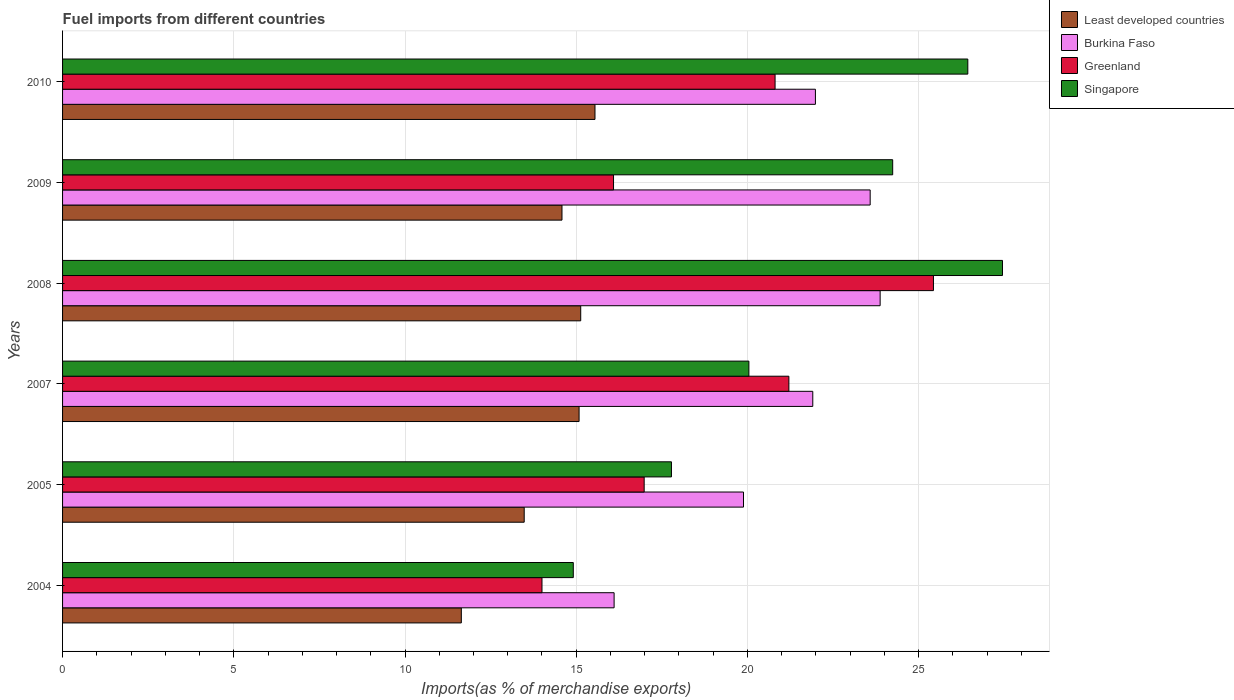How many groups of bars are there?
Offer a terse response. 6. Are the number of bars per tick equal to the number of legend labels?
Offer a terse response. Yes. Are the number of bars on each tick of the Y-axis equal?
Give a very brief answer. Yes. How many bars are there on the 2nd tick from the top?
Make the answer very short. 4. How many bars are there on the 4th tick from the bottom?
Your response must be concise. 4. What is the label of the 2nd group of bars from the top?
Your answer should be compact. 2009. What is the percentage of imports to different countries in Burkina Faso in 2010?
Ensure brevity in your answer.  21.98. Across all years, what is the maximum percentage of imports to different countries in Greenland?
Provide a succinct answer. 25.43. Across all years, what is the minimum percentage of imports to different countries in Burkina Faso?
Give a very brief answer. 16.11. In which year was the percentage of imports to different countries in Burkina Faso minimum?
Provide a succinct answer. 2004. What is the total percentage of imports to different countries in Least developed countries in the graph?
Your response must be concise. 85.47. What is the difference between the percentage of imports to different countries in Singapore in 2004 and that in 2009?
Your answer should be very brief. -9.33. What is the difference between the percentage of imports to different countries in Least developed countries in 2005 and the percentage of imports to different countries in Burkina Faso in 2007?
Keep it short and to the point. -8.43. What is the average percentage of imports to different countries in Least developed countries per year?
Provide a short and direct response. 14.25. In the year 2008, what is the difference between the percentage of imports to different countries in Burkina Faso and percentage of imports to different countries in Greenland?
Your answer should be very brief. -1.56. What is the ratio of the percentage of imports to different countries in Greenland in 2009 to that in 2010?
Provide a succinct answer. 0.77. Is the percentage of imports to different countries in Singapore in 2004 less than that in 2005?
Provide a succinct answer. Yes. What is the difference between the highest and the second highest percentage of imports to different countries in Greenland?
Ensure brevity in your answer.  4.22. What is the difference between the highest and the lowest percentage of imports to different countries in Burkina Faso?
Provide a short and direct response. 7.77. What does the 2nd bar from the top in 2010 represents?
Your response must be concise. Greenland. What does the 3rd bar from the bottom in 2007 represents?
Provide a short and direct response. Greenland. How many bars are there?
Provide a short and direct response. 24. Are all the bars in the graph horizontal?
Your answer should be compact. Yes. How many years are there in the graph?
Offer a terse response. 6. Does the graph contain any zero values?
Give a very brief answer. No. Does the graph contain grids?
Give a very brief answer. Yes. Where does the legend appear in the graph?
Offer a terse response. Top right. How many legend labels are there?
Your answer should be compact. 4. What is the title of the graph?
Your answer should be very brief. Fuel imports from different countries. Does "Bahamas" appear as one of the legend labels in the graph?
Offer a terse response. No. What is the label or title of the X-axis?
Make the answer very short. Imports(as % of merchandise exports). What is the label or title of the Y-axis?
Provide a succinct answer. Years. What is the Imports(as % of merchandise exports) in Least developed countries in 2004?
Your answer should be compact. 11.64. What is the Imports(as % of merchandise exports) of Burkina Faso in 2004?
Provide a succinct answer. 16.11. What is the Imports(as % of merchandise exports) in Greenland in 2004?
Your answer should be very brief. 14. What is the Imports(as % of merchandise exports) of Singapore in 2004?
Make the answer very short. 14.91. What is the Imports(as % of merchandise exports) in Least developed countries in 2005?
Ensure brevity in your answer.  13.48. What is the Imports(as % of merchandise exports) in Burkina Faso in 2005?
Provide a short and direct response. 19.88. What is the Imports(as % of merchandise exports) of Greenland in 2005?
Your answer should be very brief. 16.98. What is the Imports(as % of merchandise exports) in Singapore in 2005?
Provide a succinct answer. 17.78. What is the Imports(as % of merchandise exports) of Least developed countries in 2007?
Provide a succinct answer. 15.08. What is the Imports(as % of merchandise exports) in Burkina Faso in 2007?
Give a very brief answer. 21.91. What is the Imports(as % of merchandise exports) in Greenland in 2007?
Ensure brevity in your answer.  21.21. What is the Imports(as % of merchandise exports) in Singapore in 2007?
Your answer should be very brief. 20.04. What is the Imports(as % of merchandise exports) of Least developed countries in 2008?
Your answer should be compact. 15.13. What is the Imports(as % of merchandise exports) of Burkina Faso in 2008?
Your response must be concise. 23.87. What is the Imports(as % of merchandise exports) in Greenland in 2008?
Make the answer very short. 25.43. What is the Imports(as % of merchandise exports) of Singapore in 2008?
Offer a terse response. 27.45. What is the Imports(as % of merchandise exports) of Least developed countries in 2009?
Offer a terse response. 14.58. What is the Imports(as % of merchandise exports) in Burkina Faso in 2009?
Offer a very short reply. 23.58. What is the Imports(as % of merchandise exports) in Greenland in 2009?
Give a very brief answer. 16.09. What is the Imports(as % of merchandise exports) in Singapore in 2009?
Give a very brief answer. 24.24. What is the Imports(as % of merchandise exports) of Least developed countries in 2010?
Keep it short and to the point. 15.55. What is the Imports(as % of merchandise exports) in Burkina Faso in 2010?
Provide a short and direct response. 21.98. What is the Imports(as % of merchandise exports) in Greenland in 2010?
Make the answer very short. 20.81. What is the Imports(as % of merchandise exports) in Singapore in 2010?
Make the answer very short. 26.43. Across all years, what is the maximum Imports(as % of merchandise exports) in Least developed countries?
Offer a terse response. 15.55. Across all years, what is the maximum Imports(as % of merchandise exports) of Burkina Faso?
Your response must be concise. 23.87. Across all years, what is the maximum Imports(as % of merchandise exports) of Greenland?
Make the answer very short. 25.43. Across all years, what is the maximum Imports(as % of merchandise exports) in Singapore?
Your response must be concise. 27.45. Across all years, what is the minimum Imports(as % of merchandise exports) in Least developed countries?
Provide a short and direct response. 11.64. Across all years, what is the minimum Imports(as % of merchandise exports) in Burkina Faso?
Provide a short and direct response. 16.11. Across all years, what is the minimum Imports(as % of merchandise exports) of Greenland?
Ensure brevity in your answer.  14. Across all years, what is the minimum Imports(as % of merchandise exports) in Singapore?
Give a very brief answer. 14.91. What is the total Imports(as % of merchandise exports) in Least developed countries in the graph?
Provide a short and direct response. 85.47. What is the total Imports(as % of merchandise exports) in Burkina Faso in the graph?
Your answer should be compact. 127.34. What is the total Imports(as % of merchandise exports) in Greenland in the graph?
Give a very brief answer. 114.52. What is the total Imports(as % of merchandise exports) in Singapore in the graph?
Offer a terse response. 130.86. What is the difference between the Imports(as % of merchandise exports) in Least developed countries in 2004 and that in 2005?
Ensure brevity in your answer.  -1.84. What is the difference between the Imports(as % of merchandise exports) in Burkina Faso in 2004 and that in 2005?
Offer a very short reply. -3.78. What is the difference between the Imports(as % of merchandise exports) of Greenland in 2004 and that in 2005?
Provide a succinct answer. -2.98. What is the difference between the Imports(as % of merchandise exports) in Singapore in 2004 and that in 2005?
Provide a short and direct response. -2.87. What is the difference between the Imports(as % of merchandise exports) of Least developed countries in 2004 and that in 2007?
Your answer should be compact. -3.44. What is the difference between the Imports(as % of merchandise exports) of Burkina Faso in 2004 and that in 2007?
Provide a short and direct response. -5.8. What is the difference between the Imports(as % of merchandise exports) in Greenland in 2004 and that in 2007?
Provide a succinct answer. -7.21. What is the difference between the Imports(as % of merchandise exports) in Singapore in 2004 and that in 2007?
Ensure brevity in your answer.  -5.13. What is the difference between the Imports(as % of merchandise exports) of Least developed countries in 2004 and that in 2008?
Provide a short and direct response. -3.49. What is the difference between the Imports(as % of merchandise exports) of Burkina Faso in 2004 and that in 2008?
Your answer should be very brief. -7.77. What is the difference between the Imports(as % of merchandise exports) of Greenland in 2004 and that in 2008?
Give a very brief answer. -11.43. What is the difference between the Imports(as % of merchandise exports) in Singapore in 2004 and that in 2008?
Give a very brief answer. -12.53. What is the difference between the Imports(as % of merchandise exports) of Least developed countries in 2004 and that in 2009?
Give a very brief answer. -2.94. What is the difference between the Imports(as % of merchandise exports) in Burkina Faso in 2004 and that in 2009?
Provide a short and direct response. -7.48. What is the difference between the Imports(as % of merchandise exports) in Greenland in 2004 and that in 2009?
Keep it short and to the point. -2.09. What is the difference between the Imports(as % of merchandise exports) in Singapore in 2004 and that in 2009?
Your response must be concise. -9.33. What is the difference between the Imports(as % of merchandise exports) of Least developed countries in 2004 and that in 2010?
Your response must be concise. -3.9. What is the difference between the Imports(as % of merchandise exports) of Burkina Faso in 2004 and that in 2010?
Your answer should be compact. -5.88. What is the difference between the Imports(as % of merchandise exports) in Greenland in 2004 and that in 2010?
Your response must be concise. -6.81. What is the difference between the Imports(as % of merchandise exports) of Singapore in 2004 and that in 2010?
Provide a succinct answer. -11.52. What is the difference between the Imports(as % of merchandise exports) of Least developed countries in 2005 and that in 2007?
Keep it short and to the point. -1.6. What is the difference between the Imports(as % of merchandise exports) of Burkina Faso in 2005 and that in 2007?
Provide a succinct answer. -2.02. What is the difference between the Imports(as % of merchandise exports) of Greenland in 2005 and that in 2007?
Provide a succinct answer. -4.23. What is the difference between the Imports(as % of merchandise exports) in Singapore in 2005 and that in 2007?
Ensure brevity in your answer.  -2.26. What is the difference between the Imports(as % of merchandise exports) of Least developed countries in 2005 and that in 2008?
Offer a terse response. -1.65. What is the difference between the Imports(as % of merchandise exports) of Burkina Faso in 2005 and that in 2008?
Offer a very short reply. -3.99. What is the difference between the Imports(as % of merchandise exports) in Greenland in 2005 and that in 2008?
Keep it short and to the point. -8.45. What is the difference between the Imports(as % of merchandise exports) in Singapore in 2005 and that in 2008?
Give a very brief answer. -9.67. What is the difference between the Imports(as % of merchandise exports) of Least developed countries in 2005 and that in 2009?
Your response must be concise. -1.1. What is the difference between the Imports(as % of merchandise exports) of Burkina Faso in 2005 and that in 2009?
Your response must be concise. -3.7. What is the difference between the Imports(as % of merchandise exports) in Greenland in 2005 and that in 2009?
Provide a short and direct response. 0.9. What is the difference between the Imports(as % of merchandise exports) of Singapore in 2005 and that in 2009?
Provide a short and direct response. -6.46. What is the difference between the Imports(as % of merchandise exports) of Least developed countries in 2005 and that in 2010?
Keep it short and to the point. -2.07. What is the difference between the Imports(as % of merchandise exports) of Burkina Faso in 2005 and that in 2010?
Your answer should be compact. -2.1. What is the difference between the Imports(as % of merchandise exports) of Greenland in 2005 and that in 2010?
Make the answer very short. -3.82. What is the difference between the Imports(as % of merchandise exports) of Singapore in 2005 and that in 2010?
Provide a short and direct response. -8.65. What is the difference between the Imports(as % of merchandise exports) of Least developed countries in 2007 and that in 2008?
Ensure brevity in your answer.  -0.05. What is the difference between the Imports(as % of merchandise exports) in Burkina Faso in 2007 and that in 2008?
Keep it short and to the point. -1.97. What is the difference between the Imports(as % of merchandise exports) of Greenland in 2007 and that in 2008?
Keep it short and to the point. -4.22. What is the difference between the Imports(as % of merchandise exports) of Singapore in 2007 and that in 2008?
Your response must be concise. -7.41. What is the difference between the Imports(as % of merchandise exports) of Least developed countries in 2007 and that in 2009?
Your response must be concise. 0.5. What is the difference between the Imports(as % of merchandise exports) in Burkina Faso in 2007 and that in 2009?
Your answer should be very brief. -1.68. What is the difference between the Imports(as % of merchandise exports) of Greenland in 2007 and that in 2009?
Give a very brief answer. 5.12. What is the difference between the Imports(as % of merchandise exports) in Singapore in 2007 and that in 2009?
Give a very brief answer. -4.2. What is the difference between the Imports(as % of merchandise exports) in Least developed countries in 2007 and that in 2010?
Ensure brevity in your answer.  -0.46. What is the difference between the Imports(as % of merchandise exports) in Burkina Faso in 2007 and that in 2010?
Offer a very short reply. -0.08. What is the difference between the Imports(as % of merchandise exports) of Greenland in 2007 and that in 2010?
Provide a succinct answer. 0.4. What is the difference between the Imports(as % of merchandise exports) of Singapore in 2007 and that in 2010?
Give a very brief answer. -6.39. What is the difference between the Imports(as % of merchandise exports) in Least developed countries in 2008 and that in 2009?
Provide a succinct answer. 0.55. What is the difference between the Imports(as % of merchandise exports) of Burkina Faso in 2008 and that in 2009?
Provide a succinct answer. 0.29. What is the difference between the Imports(as % of merchandise exports) in Greenland in 2008 and that in 2009?
Make the answer very short. 9.34. What is the difference between the Imports(as % of merchandise exports) in Singapore in 2008 and that in 2009?
Your answer should be compact. 3.21. What is the difference between the Imports(as % of merchandise exports) of Least developed countries in 2008 and that in 2010?
Offer a terse response. -0.42. What is the difference between the Imports(as % of merchandise exports) in Burkina Faso in 2008 and that in 2010?
Make the answer very short. 1.89. What is the difference between the Imports(as % of merchandise exports) in Greenland in 2008 and that in 2010?
Your answer should be very brief. 4.62. What is the difference between the Imports(as % of merchandise exports) in Singapore in 2008 and that in 2010?
Make the answer very short. 1.01. What is the difference between the Imports(as % of merchandise exports) in Least developed countries in 2009 and that in 2010?
Ensure brevity in your answer.  -0.96. What is the difference between the Imports(as % of merchandise exports) of Burkina Faso in 2009 and that in 2010?
Offer a very short reply. 1.6. What is the difference between the Imports(as % of merchandise exports) of Greenland in 2009 and that in 2010?
Your response must be concise. -4.72. What is the difference between the Imports(as % of merchandise exports) in Singapore in 2009 and that in 2010?
Provide a succinct answer. -2.19. What is the difference between the Imports(as % of merchandise exports) in Least developed countries in 2004 and the Imports(as % of merchandise exports) in Burkina Faso in 2005?
Provide a succinct answer. -8.24. What is the difference between the Imports(as % of merchandise exports) of Least developed countries in 2004 and the Imports(as % of merchandise exports) of Greenland in 2005?
Make the answer very short. -5.34. What is the difference between the Imports(as % of merchandise exports) of Least developed countries in 2004 and the Imports(as % of merchandise exports) of Singapore in 2005?
Your answer should be very brief. -6.14. What is the difference between the Imports(as % of merchandise exports) of Burkina Faso in 2004 and the Imports(as % of merchandise exports) of Greenland in 2005?
Provide a short and direct response. -0.88. What is the difference between the Imports(as % of merchandise exports) in Burkina Faso in 2004 and the Imports(as % of merchandise exports) in Singapore in 2005?
Ensure brevity in your answer.  -1.67. What is the difference between the Imports(as % of merchandise exports) of Greenland in 2004 and the Imports(as % of merchandise exports) of Singapore in 2005?
Ensure brevity in your answer.  -3.78. What is the difference between the Imports(as % of merchandise exports) in Least developed countries in 2004 and the Imports(as % of merchandise exports) in Burkina Faso in 2007?
Give a very brief answer. -10.26. What is the difference between the Imports(as % of merchandise exports) in Least developed countries in 2004 and the Imports(as % of merchandise exports) in Greenland in 2007?
Offer a very short reply. -9.57. What is the difference between the Imports(as % of merchandise exports) of Least developed countries in 2004 and the Imports(as % of merchandise exports) of Singapore in 2007?
Keep it short and to the point. -8.4. What is the difference between the Imports(as % of merchandise exports) of Burkina Faso in 2004 and the Imports(as % of merchandise exports) of Greenland in 2007?
Keep it short and to the point. -5.1. What is the difference between the Imports(as % of merchandise exports) in Burkina Faso in 2004 and the Imports(as % of merchandise exports) in Singapore in 2007?
Provide a succinct answer. -3.94. What is the difference between the Imports(as % of merchandise exports) in Greenland in 2004 and the Imports(as % of merchandise exports) in Singapore in 2007?
Make the answer very short. -6.04. What is the difference between the Imports(as % of merchandise exports) in Least developed countries in 2004 and the Imports(as % of merchandise exports) in Burkina Faso in 2008?
Your response must be concise. -12.23. What is the difference between the Imports(as % of merchandise exports) in Least developed countries in 2004 and the Imports(as % of merchandise exports) in Greenland in 2008?
Provide a succinct answer. -13.79. What is the difference between the Imports(as % of merchandise exports) of Least developed countries in 2004 and the Imports(as % of merchandise exports) of Singapore in 2008?
Your answer should be very brief. -15.8. What is the difference between the Imports(as % of merchandise exports) of Burkina Faso in 2004 and the Imports(as % of merchandise exports) of Greenland in 2008?
Provide a short and direct response. -9.33. What is the difference between the Imports(as % of merchandise exports) of Burkina Faso in 2004 and the Imports(as % of merchandise exports) of Singapore in 2008?
Your response must be concise. -11.34. What is the difference between the Imports(as % of merchandise exports) of Greenland in 2004 and the Imports(as % of merchandise exports) of Singapore in 2008?
Keep it short and to the point. -13.45. What is the difference between the Imports(as % of merchandise exports) of Least developed countries in 2004 and the Imports(as % of merchandise exports) of Burkina Faso in 2009?
Offer a very short reply. -11.94. What is the difference between the Imports(as % of merchandise exports) of Least developed countries in 2004 and the Imports(as % of merchandise exports) of Greenland in 2009?
Your answer should be compact. -4.44. What is the difference between the Imports(as % of merchandise exports) of Least developed countries in 2004 and the Imports(as % of merchandise exports) of Singapore in 2009?
Provide a short and direct response. -12.6. What is the difference between the Imports(as % of merchandise exports) in Burkina Faso in 2004 and the Imports(as % of merchandise exports) in Greenland in 2009?
Keep it short and to the point. 0.02. What is the difference between the Imports(as % of merchandise exports) of Burkina Faso in 2004 and the Imports(as % of merchandise exports) of Singapore in 2009?
Ensure brevity in your answer.  -8.13. What is the difference between the Imports(as % of merchandise exports) in Greenland in 2004 and the Imports(as % of merchandise exports) in Singapore in 2009?
Offer a very short reply. -10.24. What is the difference between the Imports(as % of merchandise exports) in Least developed countries in 2004 and the Imports(as % of merchandise exports) in Burkina Faso in 2010?
Offer a very short reply. -10.34. What is the difference between the Imports(as % of merchandise exports) in Least developed countries in 2004 and the Imports(as % of merchandise exports) in Greenland in 2010?
Offer a terse response. -9.16. What is the difference between the Imports(as % of merchandise exports) in Least developed countries in 2004 and the Imports(as % of merchandise exports) in Singapore in 2010?
Your answer should be compact. -14.79. What is the difference between the Imports(as % of merchandise exports) in Burkina Faso in 2004 and the Imports(as % of merchandise exports) in Greenland in 2010?
Make the answer very short. -4.7. What is the difference between the Imports(as % of merchandise exports) in Burkina Faso in 2004 and the Imports(as % of merchandise exports) in Singapore in 2010?
Your answer should be very brief. -10.33. What is the difference between the Imports(as % of merchandise exports) of Greenland in 2004 and the Imports(as % of merchandise exports) of Singapore in 2010?
Your answer should be very brief. -12.44. What is the difference between the Imports(as % of merchandise exports) in Least developed countries in 2005 and the Imports(as % of merchandise exports) in Burkina Faso in 2007?
Offer a very short reply. -8.43. What is the difference between the Imports(as % of merchandise exports) in Least developed countries in 2005 and the Imports(as % of merchandise exports) in Greenland in 2007?
Ensure brevity in your answer.  -7.73. What is the difference between the Imports(as % of merchandise exports) in Least developed countries in 2005 and the Imports(as % of merchandise exports) in Singapore in 2007?
Your answer should be very brief. -6.56. What is the difference between the Imports(as % of merchandise exports) in Burkina Faso in 2005 and the Imports(as % of merchandise exports) in Greenland in 2007?
Ensure brevity in your answer.  -1.33. What is the difference between the Imports(as % of merchandise exports) of Burkina Faso in 2005 and the Imports(as % of merchandise exports) of Singapore in 2007?
Offer a terse response. -0.16. What is the difference between the Imports(as % of merchandise exports) of Greenland in 2005 and the Imports(as % of merchandise exports) of Singapore in 2007?
Give a very brief answer. -3.06. What is the difference between the Imports(as % of merchandise exports) in Least developed countries in 2005 and the Imports(as % of merchandise exports) in Burkina Faso in 2008?
Keep it short and to the point. -10.39. What is the difference between the Imports(as % of merchandise exports) of Least developed countries in 2005 and the Imports(as % of merchandise exports) of Greenland in 2008?
Give a very brief answer. -11.95. What is the difference between the Imports(as % of merchandise exports) of Least developed countries in 2005 and the Imports(as % of merchandise exports) of Singapore in 2008?
Offer a very short reply. -13.97. What is the difference between the Imports(as % of merchandise exports) in Burkina Faso in 2005 and the Imports(as % of merchandise exports) in Greenland in 2008?
Keep it short and to the point. -5.55. What is the difference between the Imports(as % of merchandise exports) of Burkina Faso in 2005 and the Imports(as % of merchandise exports) of Singapore in 2008?
Give a very brief answer. -7.56. What is the difference between the Imports(as % of merchandise exports) in Greenland in 2005 and the Imports(as % of merchandise exports) in Singapore in 2008?
Ensure brevity in your answer.  -10.46. What is the difference between the Imports(as % of merchandise exports) in Least developed countries in 2005 and the Imports(as % of merchandise exports) in Burkina Faso in 2009?
Provide a short and direct response. -10.1. What is the difference between the Imports(as % of merchandise exports) of Least developed countries in 2005 and the Imports(as % of merchandise exports) of Greenland in 2009?
Provide a short and direct response. -2.61. What is the difference between the Imports(as % of merchandise exports) of Least developed countries in 2005 and the Imports(as % of merchandise exports) of Singapore in 2009?
Provide a short and direct response. -10.76. What is the difference between the Imports(as % of merchandise exports) of Burkina Faso in 2005 and the Imports(as % of merchandise exports) of Greenland in 2009?
Offer a terse response. 3.8. What is the difference between the Imports(as % of merchandise exports) in Burkina Faso in 2005 and the Imports(as % of merchandise exports) in Singapore in 2009?
Your answer should be very brief. -4.36. What is the difference between the Imports(as % of merchandise exports) of Greenland in 2005 and the Imports(as % of merchandise exports) of Singapore in 2009?
Provide a short and direct response. -7.26. What is the difference between the Imports(as % of merchandise exports) in Least developed countries in 2005 and the Imports(as % of merchandise exports) in Burkina Faso in 2010?
Your answer should be compact. -8.5. What is the difference between the Imports(as % of merchandise exports) of Least developed countries in 2005 and the Imports(as % of merchandise exports) of Greenland in 2010?
Offer a terse response. -7.33. What is the difference between the Imports(as % of merchandise exports) of Least developed countries in 2005 and the Imports(as % of merchandise exports) of Singapore in 2010?
Provide a succinct answer. -12.95. What is the difference between the Imports(as % of merchandise exports) of Burkina Faso in 2005 and the Imports(as % of merchandise exports) of Greenland in 2010?
Ensure brevity in your answer.  -0.92. What is the difference between the Imports(as % of merchandise exports) of Burkina Faso in 2005 and the Imports(as % of merchandise exports) of Singapore in 2010?
Your answer should be compact. -6.55. What is the difference between the Imports(as % of merchandise exports) in Greenland in 2005 and the Imports(as % of merchandise exports) in Singapore in 2010?
Make the answer very short. -9.45. What is the difference between the Imports(as % of merchandise exports) in Least developed countries in 2007 and the Imports(as % of merchandise exports) in Burkina Faso in 2008?
Give a very brief answer. -8.79. What is the difference between the Imports(as % of merchandise exports) in Least developed countries in 2007 and the Imports(as % of merchandise exports) in Greenland in 2008?
Keep it short and to the point. -10.35. What is the difference between the Imports(as % of merchandise exports) in Least developed countries in 2007 and the Imports(as % of merchandise exports) in Singapore in 2008?
Provide a short and direct response. -12.36. What is the difference between the Imports(as % of merchandise exports) in Burkina Faso in 2007 and the Imports(as % of merchandise exports) in Greenland in 2008?
Make the answer very short. -3.52. What is the difference between the Imports(as % of merchandise exports) of Burkina Faso in 2007 and the Imports(as % of merchandise exports) of Singapore in 2008?
Your response must be concise. -5.54. What is the difference between the Imports(as % of merchandise exports) of Greenland in 2007 and the Imports(as % of merchandise exports) of Singapore in 2008?
Your answer should be very brief. -6.24. What is the difference between the Imports(as % of merchandise exports) of Least developed countries in 2007 and the Imports(as % of merchandise exports) of Burkina Faso in 2009?
Provide a short and direct response. -8.5. What is the difference between the Imports(as % of merchandise exports) in Least developed countries in 2007 and the Imports(as % of merchandise exports) in Greenland in 2009?
Offer a very short reply. -1.01. What is the difference between the Imports(as % of merchandise exports) in Least developed countries in 2007 and the Imports(as % of merchandise exports) in Singapore in 2009?
Give a very brief answer. -9.16. What is the difference between the Imports(as % of merchandise exports) in Burkina Faso in 2007 and the Imports(as % of merchandise exports) in Greenland in 2009?
Give a very brief answer. 5.82. What is the difference between the Imports(as % of merchandise exports) of Burkina Faso in 2007 and the Imports(as % of merchandise exports) of Singapore in 2009?
Offer a terse response. -2.33. What is the difference between the Imports(as % of merchandise exports) of Greenland in 2007 and the Imports(as % of merchandise exports) of Singapore in 2009?
Offer a very short reply. -3.03. What is the difference between the Imports(as % of merchandise exports) of Least developed countries in 2007 and the Imports(as % of merchandise exports) of Burkina Faso in 2010?
Offer a very short reply. -6.9. What is the difference between the Imports(as % of merchandise exports) in Least developed countries in 2007 and the Imports(as % of merchandise exports) in Greenland in 2010?
Give a very brief answer. -5.72. What is the difference between the Imports(as % of merchandise exports) in Least developed countries in 2007 and the Imports(as % of merchandise exports) in Singapore in 2010?
Ensure brevity in your answer.  -11.35. What is the difference between the Imports(as % of merchandise exports) in Burkina Faso in 2007 and the Imports(as % of merchandise exports) in Greenland in 2010?
Provide a succinct answer. 1.1. What is the difference between the Imports(as % of merchandise exports) of Burkina Faso in 2007 and the Imports(as % of merchandise exports) of Singapore in 2010?
Offer a very short reply. -4.53. What is the difference between the Imports(as % of merchandise exports) of Greenland in 2007 and the Imports(as % of merchandise exports) of Singapore in 2010?
Your answer should be compact. -5.23. What is the difference between the Imports(as % of merchandise exports) of Least developed countries in 2008 and the Imports(as % of merchandise exports) of Burkina Faso in 2009?
Offer a very short reply. -8.45. What is the difference between the Imports(as % of merchandise exports) of Least developed countries in 2008 and the Imports(as % of merchandise exports) of Greenland in 2009?
Ensure brevity in your answer.  -0.96. What is the difference between the Imports(as % of merchandise exports) of Least developed countries in 2008 and the Imports(as % of merchandise exports) of Singapore in 2009?
Your response must be concise. -9.11. What is the difference between the Imports(as % of merchandise exports) of Burkina Faso in 2008 and the Imports(as % of merchandise exports) of Greenland in 2009?
Ensure brevity in your answer.  7.79. What is the difference between the Imports(as % of merchandise exports) of Burkina Faso in 2008 and the Imports(as % of merchandise exports) of Singapore in 2009?
Your answer should be very brief. -0.37. What is the difference between the Imports(as % of merchandise exports) in Greenland in 2008 and the Imports(as % of merchandise exports) in Singapore in 2009?
Your answer should be compact. 1.19. What is the difference between the Imports(as % of merchandise exports) of Least developed countries in 2008 and the Imports(as % of merchandise exports) of Burkina Faso in 2010?
Ensure brevity in your answer.  -6.85. What is the difference between the Imports(as % of merchandise exports) of Least developed countries in 2008 and the Imports(as % of merchandise exports) of Greenland in 2010?
Offer a very short reply. -5.68. What is the difference between the Imports(as % of merchandise exports) in Least developed countries in 2008 and the Imports(as % of merchandise exports) in Singapore in 2010?
Your answer should be compact. -11.3. What is the difference between the Imports(as % of merchandise exports) in Burkina Faso in 2008 and the Imports(as % of merchandise exports) in Greenland in 2010?
Ensure brevity in your answer.  3.07. What is the difference between the Imports(as % of merchandise exports) of Burkina Faso in 2008 and the Imports(as % of merchandise exports) of Singapore in 2010?
Keep it short and to the point. -2.56. What is the difference between the Imports(as % of merchandise exports) in Greenland in 2008 and the Imports(as % of merchandise exports) in Singapore in 2010?
Your response must be concise. -1. What is the difference between the Imports(as % of merchandise exports) in Least developed countries in 2009 and the Imports(as % of merchandise exports) in Burkina Faso in 2010?
Keep it short and to the point. -7.4. What is the difference between the Imports(as % of merchandise exports) in Least developed countries in 2009 and the Imports(as % of merchandise exports) in Greenland in 2010?
Ensure brevity in your answer.  -6.22. What is the difference between the Imports(as % of merchandise exports) in Least developed countries in 2009 and the Imports(as % of merchandise exports) in Singapore in 2010?
Make the answer very short. -11.85. What is the difference between the Imports(as % of merchandise exports) in Burkina Faso in 2009 and the Imports(as % of merchandise exports) in Greenland in 2010?
Keep it short and to the point. 2.78. What is the difference between the Imports(as % of merchandise exports) in Burkina Faso in 2009 and the Imports(as % of merchandise exports) in Singapore in 2010?
Give a very brief answer. -2.85. What is the difference between the Imports(as % of merchandise exports) in Greenland in 2009 and the Imports(as % of merchandise exports) in Singapore in 2010?
Give a very brief answer. -10.35. What is the average Imports(as % of merchandise exports) of Least developed countries per year?
Offer a very short reply. 14.25. What is the average Imports(as % of merchandise exports) of Burkina Faso per year?
Give a very brief answer. 21.22. What is the average Imports(as % of merchandise exports) in Greenland per year?
Offer a very short reply. 19.09. What is the average Imports(as % of merchandise exports) of Singapore per year?
Your answer should be very brief. 21.81. In the year 2004, what is the difference between the Imports(as % of merchandise exports) in Least developed countries and Imports(as % of merchandise exports) in Burkina Faso?
Make the answer very short. -4.46. In the year 2004, what is the difference between the Imports(as % of merchandise exports) in Least developed countries and Imports(as % of merchandise exports) in Greenland?
Your answer should be very brief. -2.36. In the year 2004, what is the difference between the Imports(as % of merchandise exports) of Least developed countries and Imports(as % of merchandise exports) of Singapore?
Give a very brief answer. -3.27. In the year 2004, what is the difference between the Imports(as % of merchandise exports) in Burkina Faso and Imports(as % of merchandise exports) in Greenland?
Provide a succinct answer. 2.11. In the year 2004, what is the difference between the Imports(as % of merchandise exports) in Burkina Faso and Imports(as % of merchandise exports) in Singapore?
Provide a succinct answer. 1.19. In the year 2004, what is the difference between the Imports(as % of merchandise exports) in Greenland and Imports(as % of merchandise exports) in Singapore?
Offer a very short reply. -0.91. In the year 2005, what is the difference between the Imports(as % of merchandise exports) in Least developed countries and Imports(as % of merchandise exports) in Burkina Faso?
Your response must be concise. -6.4. In the year 2005, what is the difference between the Imports(as % of merchandise exports) in Least developed countries and Imports(as % of merchandise exports) in Greenland?
Your answer should be very brief. -3.5. In the year 2005, what is the difference between the Imports(as % of merchandise exports) of Least developed countries and Imports(as % of merchandise exports) of Singapore?
Offer a very short reply. -4.3. In the year 2005, what is the difference between the Imports(as % of merchandise exports) of Burkina Faso and Imports(as % of merchandise exports) of Greenland?
Provide a succinct answer. 2.9. In the year 2005, what is the difference between the Imports(as % of merchandise exports) in Burkina Faso and Imports(as % of merchandise exports) in Singapore?
Provide a succinct answer. 2.1. In the year 2005, what is the difference between the Imports(as % of merchandise exports) of Greenland and Imports(as % of merchandise exports) of Singapore?
Your response must be concise. -0.8. In the year 2007, what is the difference between the Imports(as % of merchandise exports) of Least developed countries and Imports(as % of merchandise exports) of Burkina Faso?
Keep it short and to the point. -6.82. In the year 2007, what is the difference between the Imports(as % of merchandise exports) in Least developed countries and Imports(as % of merchandise exports) in Greenland?
Offer a very short reply. -6.13. In the year 2007, what is the difference between the Imports(as % of merchandise exports) of Least developed countries and Imports(as % of merchandise exports) of Singapore?
Provide a succinct answer. -4.96. In the year 2007, what is the difference between the Imports(as % of merchandise exports) in Burkina Faso and Imports(as % of merchandise exports) in Greenland?
Offer a terse response. 0.7. In the year 2007, what is the difference between the Imports(as % of merchandise exports) in Burkina Faso and Imports(as % of merchandise exports) in Singapore?
Provide a short and direct response. 1.87. In the year 2007, what is the difference between the Imports(as % of merchandise exports) in Greenland and Imports(as % of merchandise exports) in Singapore?
Provide a short and direct response. 1.17. In the year 2008, what is the difference between the Imports(as % of merchandise exports) of Least developed countries and Imports(as % of merchandise exports) of Burkina Faso?
Provide a succinct answer. -8.74. In the year 2008, what is the difference between the Imports(as % of merchandise exports) in Least developed countries and Imports(as % of merchandise exports) in Greenland?
Offer a terse response. -10.3. In the year 2008, what is the difference between the Imports(as % of merchandise exports) of Least developed countries and Imports(as % of merchandise exports) of Singapore?
Your answer should be compact. -12.32. In the year 2008, what is the difference between the Imports(as % of merchandise exports) in Burkina Faso and Imports(as % of merchandise exports) in Greenland?
Make the answer very short. -1.56. In the year 2008, what is the difference between the Imports(as % of merchandise exports) of Burkina Faso and Imports(as % of merchandise exports) of Singapore?
Offer a very short reply. -3.57. In the year 2008, what is the difference between the Imports(as % of merchandise exports) of Greenland and Imports(as % of merchandise exports) of Singapore?
Make the answer very short. -2.02. In the year 2009, what is the difference between the Imports(as % of merchandise exports) of Least developed countries and Imports(as % of merchandise exports) of Burkina Faso?
Your answer should be compact. -9. In the year 2009, what is the difference between the Imports(as % of merchandise exports) in Least developed countries and Imports(as % of merchandise exports) in Greenland?
Keep it short and to the point. -1.5. In the year 2009, what is the difference between the Imports(as % of merchandise exports) in Least developed countries and Imports(as % of merchandise exports) in Singapore?
Offer a terse response. -9.66. In the year 2009, what is the difference between the Imports(as % of merchandise exports) in Burkina Faso and Imports(as % of merchandise exports) in Greenland?
Your answer should be compact. 7.49. In the year 2009, what is the difference between the Imports(as % of merchandise exports) in Burkina Faso and Imports(as % of merchandise exports) in Singapore?
Offer a terse response. -0.66. In the year 2009, what is the difference between the Imports(as % of merchandise exports) in Greenland and Imports(as % of merchandise exports) in Singapore?
Your answer should be compact. -8.15. In the year 2010, what is the difference between the Imports(as % of merchandise exports) in Least developed countries and Imports(as % of merchandise exports) in Burkina Faso?
Make the answer very short. -6.44. In the year 2010, what is the difference between the Imports(as % of merchandise exports) in Least developed countries and Imports(as % of merchandise exports) in Greenland?
Your answer should be very brief. -5.26. In the year 2010, what is the difference between the Imports(as % of merchandise exports) in Least developed countries and Imports(as % of merchandise exports) in Singapore?
Ensure brevity in your answer.  -10.89. In the year 2010, what is the difference between the Imports(as % of merchandise exports) in Burkina Faso and Imports(as % of merchandise exports) in Greenland?
Make the answer very short. 1.18. In the year 2010, what is the difference between the Imports(as % of merchandise exports) in Burkina Faso and Imports(as % of merchandise exports) in Singapore?
Make the answer very short. -4.45. In the year 2010, what is the difference between the Imports(as % of merchandise exports) of Greenland and Imports(as % of merchandise exports) of Singapore?
Ensure brevity in your answer.  -5.63. What is the ratio of the Imports(as % of merchandise exports) in Least developed countries in 2004 to that in 2005?
Provide a short and direct response. 0.86. What is the ratio of the Imports(as % of merchandise exports) of Burkina Faso in 2004 to that in 2005?
Keep it short and to the point. 0.81. What is the ratio of the Imports(as % of merchandise exports) in Greenland in 2004 to that in 2005?
Provide a succinct answer. 0.82. What is the ratio of the Imports(as % of merchandise exports) of Singapore in 2004 to that in 2005?
Offer a terse response. 0.84. What is the ratio of the Imports(as % of merchandise exports) in Least developed countries in 2004 to that in 2007?
Your response must be concise. 0.77. What is the ratio of the Imports(as % of merchandise exports) of Burkina Faso in 2004 to that in 2007?
Offer a terse response. 0.74. What is the ratio of the Imports(as % of merchandise exports) of Greenland in 2004 to that in 2007?
Your answer should be very brief. 0.66. What is the ratio of the Imports(as % of merchandise exports) of Singapore in 2004 to that in 2007?
Provide a succinct answer. 0.74. What is the ratio of the Imports(as % of merchandise exports) in Least developed countries in 2004 to that in 2008?
Ensure brevity in your answer.  0.77. What is the ratio of the Imports(as % of merchandise exports) of Burkina Faso in 2004 to that in 2008?
Offer a very short reply. 0.67. What is the ratio of the Imports(as % of merchandise exports) in Greenland in 2004 to that in 2008?
Keep it short and to the point. 0.55. What is the ratio of the Imports(as % of merchandise exports) in Singapore in 2004 to that in 2008?
Your response must be concise. 0.54. What is the ratio of the Imports(as % of merchandise exports) of Least developed countries in 2004 to that in 2009?
Offer a terse response. 0.8. What is the ratio of the Imports(as % of merchandise exports) in Burkina Faso in 2004 to that in 2009?
Make the answer very short. 0.68. What is the ratio of the Imports(as % of merchandise exports) in Greenland in 2004 to that in 2009?
Offer a terse response. 0.87. What is the ratio of the Imports(as % of merchandise exports) in Singapore in 2004 to that in 2009?
Offer a terse response. 0.62. What is the ratio of the Imports(as % of merchandise exports) of Least developed countries in 2004 to that in 2010?
Offer a terse response. 0.75. What is the ratio of the Imports(as % of merchandise exports) in Burkina Faso in 2004 to that in 2010?
Provide a succinct answer. 0.73. What is the ratio of the Imports(as % of merchandise exports) of Greenland in 2004 to that in 2010?
Make the answer very short. 0.67. What is the ratio of the Imports(as % of merchandise exports) in Singapore in 2004 to that in 2010?
Keep it short and to the point. 0.56. What is the ratio of the Imports(as % of merchandise exports) in Least developed countries in 2005 to that in 2007?
Your response must be concise. 0.89. What is the ratio of the Imports(as % of merchandise exports) in Burkina Faso in 2005 to that in 2007?
Provide a short and direct response. 0.91. What is the ratio of the Imports(as % of merchandise exports) in Greenland in 2005 to that in 2007?
Your response must be concise. 0.8. What is the ratio of the Imports(as % of merchandise exports) in Singapore in 2005 to that in 2007?
Make the answer very short. 0.89. What is the ratio of the Imports(as % of merchandise exports) of Least developed countries in 2005 to that in 2008?
Offer a terse response. 0.89. What is the ratio of the Imports(as % of merchandise exports) in Burkina Faso in 2005 to that in 2008?
Keep it short and to the point. 0.83. What is the ratio of the Imports(as % of merchandise exports) in Greenland in 2005 to that in 2008?
Make the answer very short. 0.67. What is the ratio of the Imports(as % of merchandise exports) of Singapore in 2005 to that in 2008?
Offer a terse response. 0.65. What is the ratio of the Imports(as % of merchandise exports) of Least developed countries in 2005 to that in 2009?
Your answer should be very brief. 0.92. What is the ratio of the Imports(as % of merchandise exports) in Burkina Faso in 2005 to that in 2009?
Your response must be concise. 0.84. What is the ratio of the Imports(as % of merchandise exports) of Greenland in 2005 to that in 2009?
Ensure brevity in your answer.  1.06. What is the ratio of the Imports(as % of merchandise exports) of Singapore in 2005 to that in 2009?
Offer a terse response. 0.73. What is the ratio of the Imports(as % of merchandise exports) of Least developed countries in 2005 to that in 2010?
Keep it short and to the point. 0.87. What is the ratio of the Imports(as % of merchandise exports) of Burkina Faso in 2005 to that in 2010?
Your answer should be very brief. 0.9. What is the ratio of the Imports(as % of merchandise exports) of Greenland in 2005 to that in 2010?
Provide a succinct answer. 0.82. What is the ratio of the Imports(as % of merchandise exports) in Singapore in 2005 to that in 2010?
Keep it short and to the point. 0.67. What is the ratio of the Imports(as % of merchandise exports) in Burkina Faso in 2007 to that in 2008?
Your answer should be very brief. 0.92. What is the ratio of the Imports(as % of merchandise exports) in Greenland in 2007 to that in 2008?
Offer a very short reply. 0.83. What is the ratio of the Imports(as % of merchandise exports) in Singapore in 2007 to that in 2008?
Your response must be concise. 0.73. What is the ratio of the Imports(as % of merchandise exports) of Least developed countries in 2007 to that in 2009?
Keep it short and to the point. 1.03. What is the ratio of the Imports(as % of merchandise exports) of Burkina Faso in 2007 to that in 2009?
Your answer should be compact. 0.93. What is the ratio of the Imports(as % of merchandise exports) of Greenland in 2007 to that in 2009?
Provide a short and direct response. 1.32. What is the ratio of the Imports(as % of merchandise exports) of Singapore in 2007 to that in 2009?
Keep it short and to the point. 0.83. What is the ratio of the Imports(as % of merchandise exports) in Least developed countries in 2007 to that in 2010?
Provide a succinct answer. 0.97. What is the ratio of the Imports(as % of merchandise exports) of Greenland in 2007 to that in 2010?
Provide a short and direct response. 1.02. What is the ratio of the Imports(as % of merchandise exports) in Singapore in 2007 to that in 2010?
Provide a short and direct response. 0.76. What is the ratio of the Imports(as % of merchandise exports) in Least developed countries in 2008 to that in 2009?
Give a very brief answer. 1.04. What is the ratio of the Imports(as % of merchandise exports) of Burkina Faso in 2008 to that in 2009?
Your answer should be compact. 1.01. What is the ratio of the Imports(as % of merchandise exports) in Greenland in 2008 to that in 2009?
Your response must be concise. 1.58. What is the ratio of the Imports(as % of merchandise exports) in Singapore in 2008 to that in 2009?
Offer a very short reply. 1.13. What is the ratio of the Imports(as % of merchandise exports) of Least developed countries in 2008 to that in 2010?
Ensure brevity in your answer.  0.97. What is the ratio of the Imports(as % of merchandise exports) of Burkina Faso in 2008 to that in 2010?
Your answer should be compact. 1.09. What is the ratio of the Imports(as % of merchandise exports) of Greenland in 2008 to that in 2010?
Your answer should be compact. 1.22. What is the ratio of the Imports(as % of merchandise exports) in Singapore in 2008 to that in 2010?
Provide a short and direct response. 1.04. What is the ratio of the Imports(as % of merchandise exports) of Least developed countries in 2009 to that in 2010?
Make the answer very short. 0.94. What is the ratio of the Imports(as % of merchandise exports) in Burkina Faso in 2009 to that in 2010?
Your answer should be compact. 1.07. What is the ratio of the Imports(as % of merchandise exports) in Greenland in 2009 to that in 2010?
Your answer should be very brief. 0.77. What is the ratio of the Imports(as % of merchandise exports) in Singapore in 2009 to that in 2010?
Your answer should be very brief. 0.92. What is the difference between the highest and the second highest Imports(as % of merchandise exports) in Least developed countries?
Make the answer very short. 0.42. What is the difference between the highest and the second highest Imports(as % of merchandise exports) in Burkina Faso?
Your answer should be compact. 0.29. What is the difference between the highest and the second highest Imports(as % of merchandise exports) of Greenland?
Give a very brief answer. 4.22. What is the difference between the highest and the second highest Imports(as % of merchandise exports) in Singapore?
Ensure brevity in your answer.  1.01. What is the difference between the highest and the lowest Imports(as % of merchandise exports) in Least developed countries?
Keep it short and to the point. 3.9. What is the difference between the highest and the lowest Imports(as % of merchandise exports) in Burkina Faso?
Keep it short and to the point. 7.77. What is the difference between the highest and the lowest Imports(as % of merchandise exports) in Greenland?
Your answer should be very brief. 11.43. What is the difference between the highest and the lowest Imports(as % of merchandise exports) in Singapore?
Make the answer very short. 12.53. 